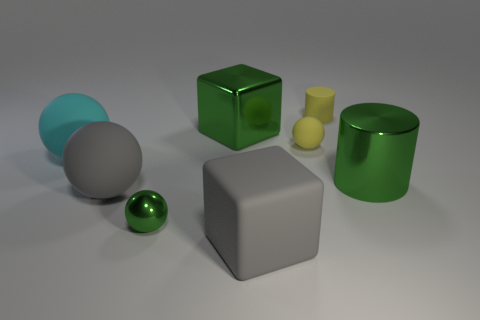Can you describe the different colors and how many objects share the same color? In the image, there are two green objects, one cyan, one yellow, one gray, and one white object. No other objects share the exact same color. Which objects are reflective? The green sphere and the green cylinder appear to have reflective surfaces, characterized by the way they catch the light and the visible reflections on their surfaces. 